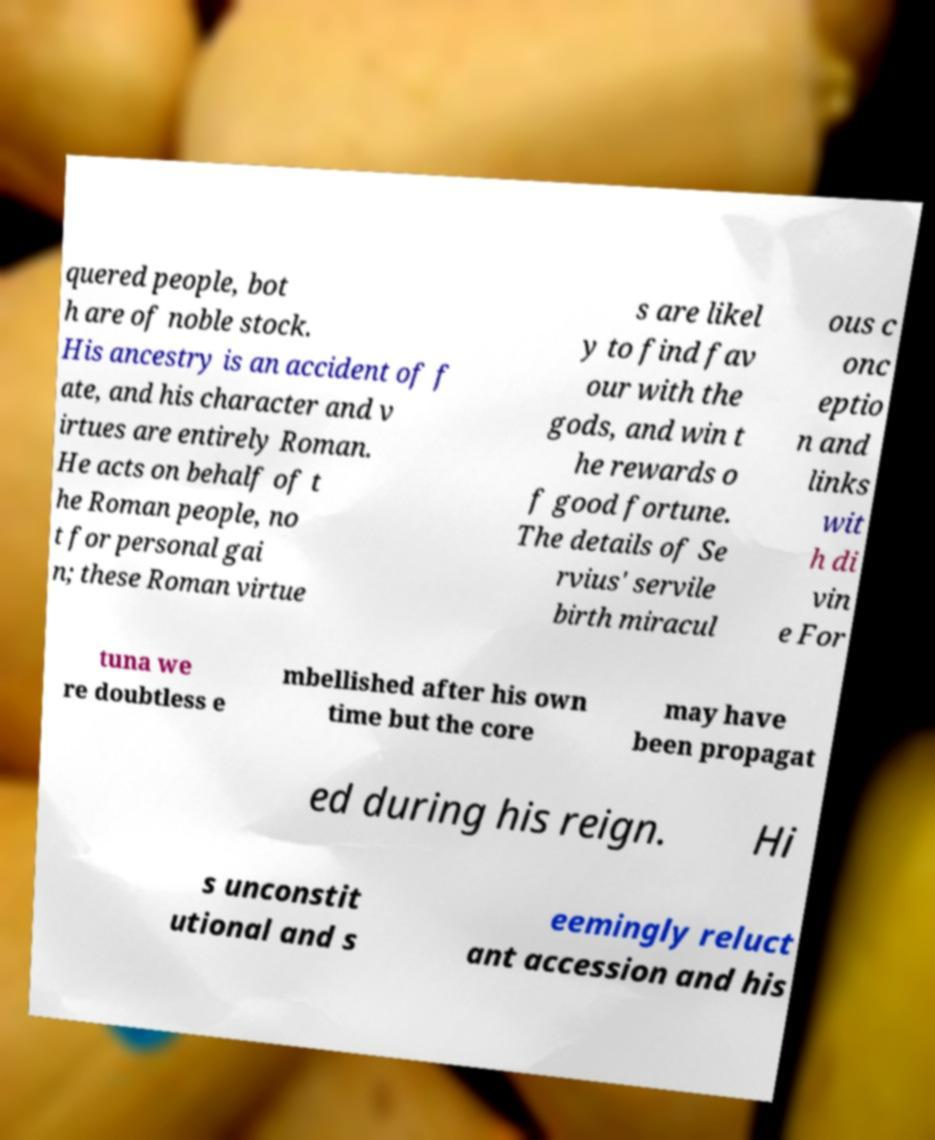Please read and relay the text visible in this image. What does it say? quered people, bot h are of noble stock. His ancestry is an accident of f ate, and his character and v irtues are entirely Roman. He acts on behalf of t he Roman people, no t for personal gai n; these Roman virtue s are likel y to find fav our with the gods, and win t he rewards o f good fortune. The details of Se rvius' servile birth miracul ous c onc eptio n and links wit h di vin e For tuna we re doubtless e mbellished after his own time but the core may have been propagat ed during his reign. Hi s unconstit utional and s eemingly reluct ant accession and his 